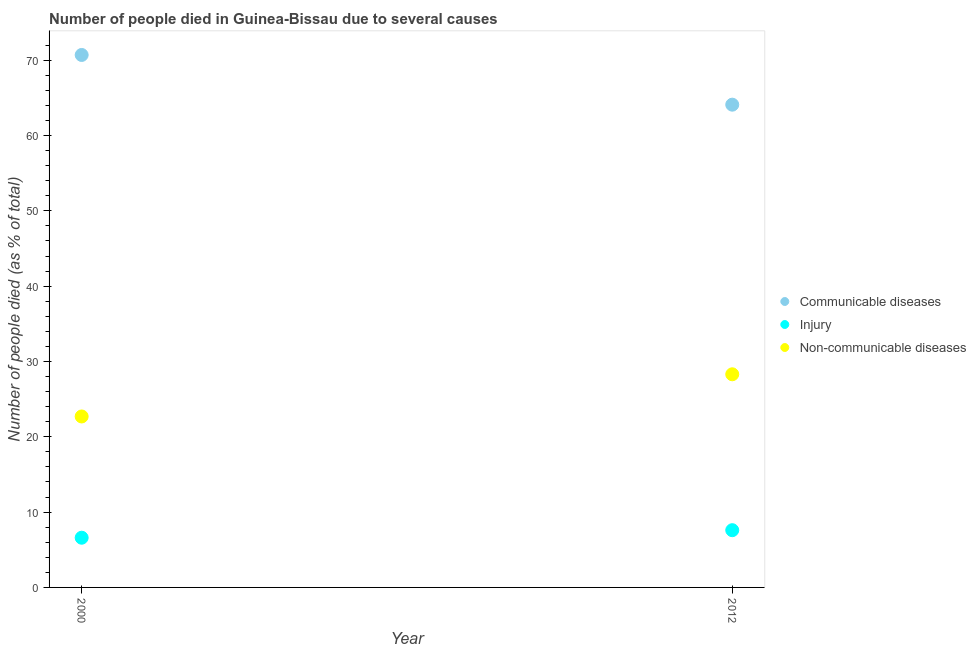Is the number of dotlines equal to the number of legend labels?
Give a very brief answer. Yes. Across all years, what is the maximum number of people who died of communicable diseases?
Make the answer very short. 70.7. Across all years, what is the minimum number of people who died of injury?
Provide a short and direct response. 6.6. In which year was the number of people who dies of non-communicable diseases minimum?
Provide a succinct answer. 2000. What is the difference between the number of people who died of injury in 2000 and that in 2012?
Provide a succinct answer. -1. What is the difference between the number of people who died of injury in 2012 and the number of people who died of communicable diseases in 2000?
Provide a short and direct response. -63.1. In the year 2012, what is the difference between the number of people who died of communicable diseases and number of people who dies of non-communicable diseases?
Your response must be concise. 35.8. What is the ratio of the number of people who died of communicable diseases in 2000 to that in 2012?
Provide a short and direct response. 1.1. In how many years, is the number of people who died of injury greater than the average number of people who died of injury taken over all years?
Offer a terse response. 1. Is it the case that in every year, the sum of the number of people who died of communicable diseases and number of people who died of injury is greater than the number of people who dies of non-communicable diseases?
Keep it short and to the point. Yes. Does the number of people who died of injury monotonically increase over the years?
Your answer should be very brief. Yes. How many years are there in the graph?
Provide a short and direct response. 2. Are the values on the major ticks of Y-axis written in scientific E-notation?
Make the answer very short. No. Where does the legend appear in the graph?
Keep it short and to the point. Center right. How many legend labels are there?
Provide a succinct answer. 3. How are the legend labels stacked?
Ensure brevity in your answer.  Vertical. What is the title of the graph?
Your response must be concise. Number of people died in Guinea-Bissau due to several causes. What is the label or title of the X-axis?
Your answer should be compact. Year. What is the label or title of the Y-axis?
Your answer should be compact. Number of people died (as % of total). What is the Number of people died (as % of total) of Communicable diseases in 2000?
Give a very brief answer. 70.7. What is the Number of people died (as % of total) in Injury in 2000?
Ensure brevity in your answer.  6.6. What is the Number of people died (as % of total) in Non-communicable diseases in 2000?
Give a very brief answer. 22.7. What is the Number of people died (as % of total) of Communicable diseases in 2012?
Offer a very short reply. 64.1. What is the Number of people died (as % of total) of Non-communicable diseases in 2012?
Your answer should be very brief. 28.3. Across all years, what is the maximum Number of people died (as % of total) of Communicable diseases?
Give a very brief answer. 70.7. Across all years, what is the maximum Number of people died (as % of total) of Injury?
Your response must be concise. 7.6. Across all years, what is the maximum Number of people died (as % of total) of Non-communicable diseases?
Offer a terse response. 28.3. Across all years, what is the minimum Number of people died (as % of total) in Communicable diseases?
Offer a terse response. 64.1. Across all years, what is the minimum Number of people died (as % of total) of Injury?
Make the answer very short. 6.6. Across all years, what is the minimum Number of people died (as % of total) in Non-communicable diseases?
Keep it short and to the point. 22.7. What is the total Number of people died (as % of total) of Communicable diseases in the graph?
Your answer should be compact. 134.8. What is the total Number of people died (as % of total) in Non-communicable diseases in the graph?
Offer a very short reply. 51. What is the difference between the Number of people died (as % of total) in Communicable diseases in 2000 and that in 2012?
Offer a very short reply. 6.6. What is the difference between the Number of people died (as % of total) of Injury in 2000 and that in 2012?
Your answer should be very brief. -1. What is the difference between the Number of people died (as % of total) of Communicable diseases in 2000 and the Number of people died (as % of total) of Injury in 2012?
Your response must be concise. 63.1. What is the difference between the Number of people died (as % of total) of Communicable diseases in 2000 and the Number of people died (as % of total) of Non-communicable diseases in 2012?
Provide a short and direct response. 42.4. What is the difference between the Number of people died (as % of total) of Injury in 2000 and the Number of people died (as % of total) of Non-communicable diseases in 2012?
Ensure brevity in your answer.  -21.7. What is the average Number of people died (as % of total) of Communicable diseases per year?
Your response must be concise. 67.4. What is the average Number of people died (as % of total) of Non-communicable diseases per year?
Your response must be concise. 25.5. In the year 2000, what is the difference between the Number of people died (as % of total) of Communicable diseases and Number of people died (as % of total) of Injury?
Provide a short and direct response. 64.1. In the year 2000, what is the difference between the Number of people died (as % of total) in Injury and Number of people died (as % of total) in Non-communicable diseases?
Provide a succinct answer. -16.1. In the year 2012, what is the difference between the Number of people died (as % of total) in Communicable diseases and Number of people died (as % of total) in Injury?
Make the answer very short. 56.5. In the year 2012, what is the difference between the Number of people died (as % of total) in Communicable diseases and Number of people died (as % of total) in Non-communicable diseases?
Make the answer very short. 35.8. In the year 2012, what is the difference between the Number of people died (as % of total) in Injury and Number of people died (as % of total) in Non-communicable diseases?
Give a very brief answer. -20.7. What is the ratio of the Number of people died (as % of total) of Communicable diseases in 2000 to that in 2012?
Provide a short and direct response. 1.1. What is the ratio of the Number of people died (as % of total) in Injury in 2000 to that in 2012?
Provide a short and direct response. 0.87. What is the ratio of the Number of people died (as % of total) in Non-communicable diseases in 2000 to that in 2012?
Give a very brief answer. 0.8. What is the difference between the highest and the second highest Number of people died (as % of total) in Communicable diseases?
Make the answer very short. 6.6. What is the difference between the highest and the second highest Number of people died (as % of total) in Non-communicable diseases?
Your response must be concise. 5.6. What is the difference between the highest and the lowest Number of people died (as % of total) in Communicable diseases?
Your answer should be compact. 6.6. 